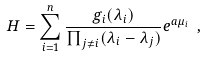Convert formula to latex. <formula><loc_0><loc_0><loc_500><loc_500>H = \sum _ { i = 1 } ^ { n } \frac { g _ { i } ( \lambda _ { i } ) } { \prod _ { j \neq i } ( \lambda _ { i } - \lambda _ { j } ) } e ^ { a \mu _ { i } } \ ,</formula> 